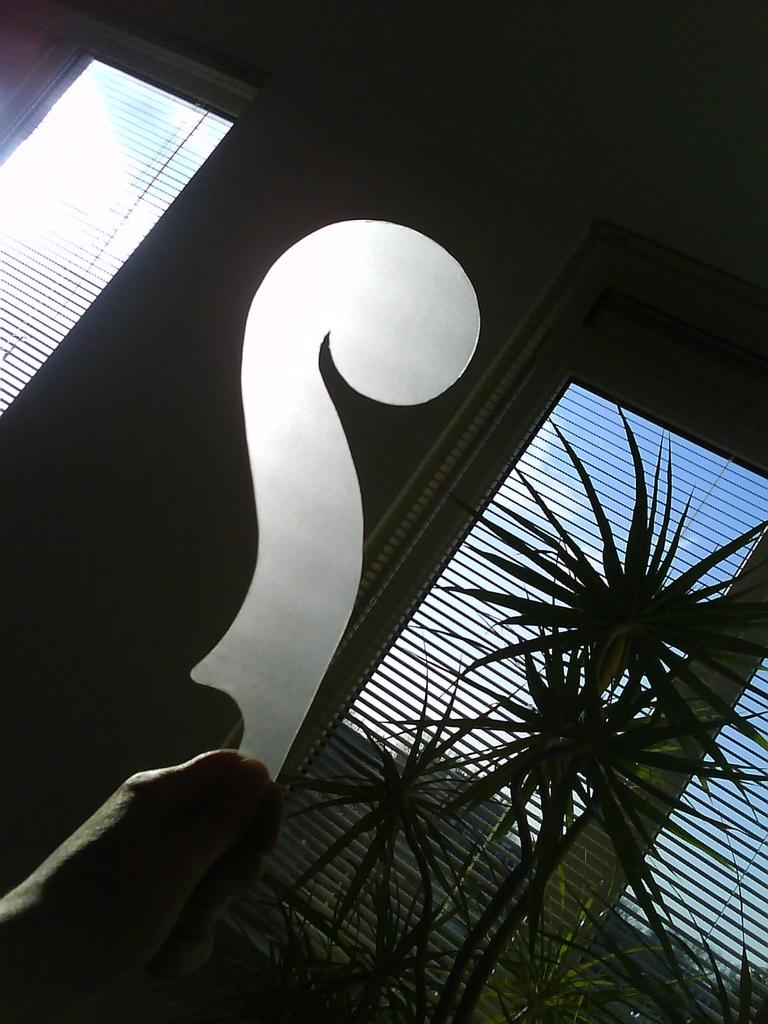How many windows can be seen in the image? There are two windows in the image. What is in front of one of the windows? There are plants in front of one of the windows. Can you describe the person in the image? There is a person in the image, and they are holding an object in their hand. How many sisters are visible in the image? There are no sisters present in the image. What type of rice is being cooked in the image? There is no rice being cooked in the image. 